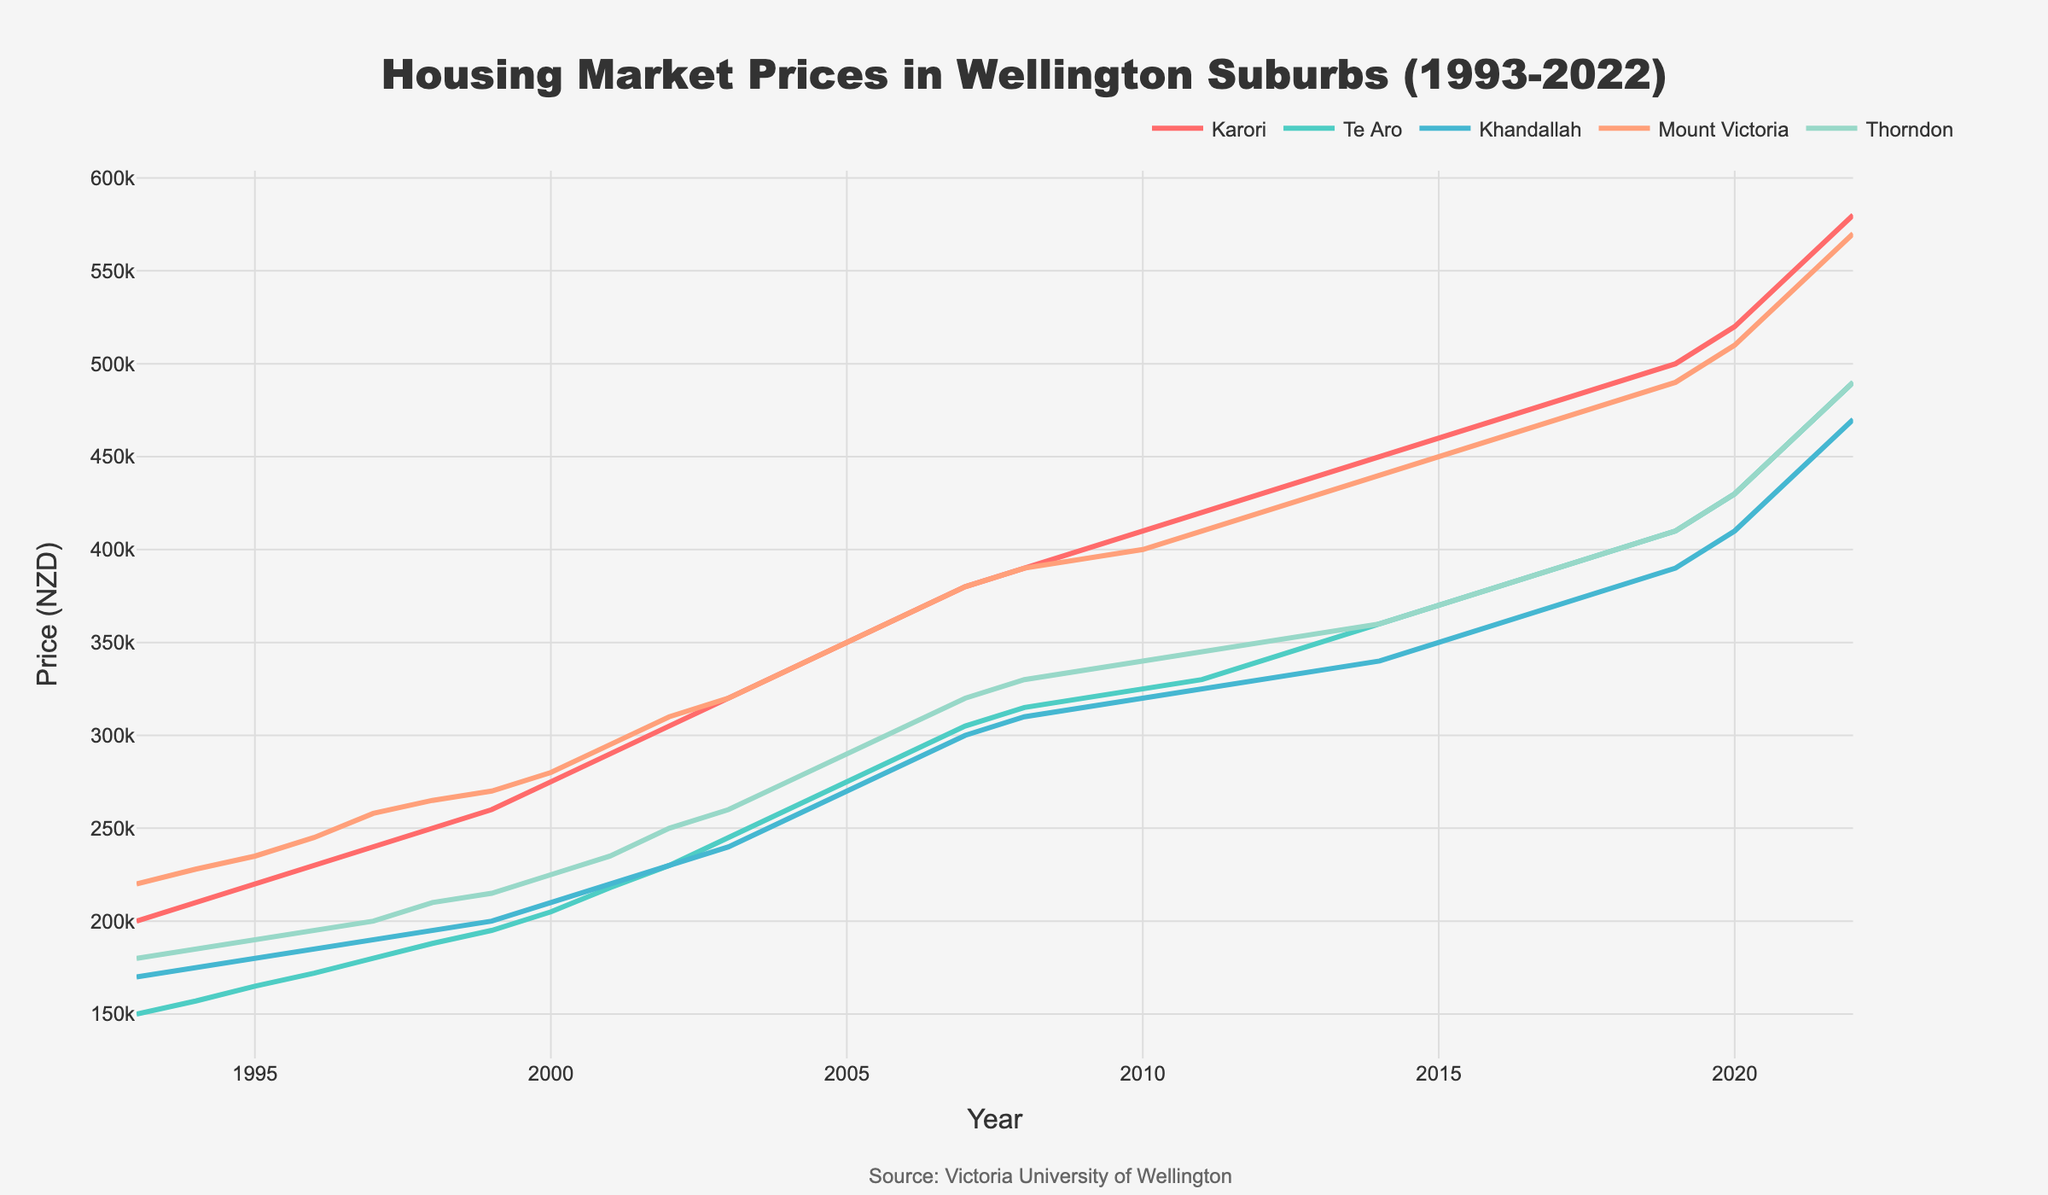What is the title of the time series plot? The title is usually found at the top of the figure and summarizes the main subject of the plot. Based on the provided data, the title should be addressing the housing market prices in Wellington suburbs over a certain period.
Answer: Housing Market Prices in Wellington Suburbs (1993-2022) Which suburb shows the highest housing market price in 2022? To determine this, look at the data points in 2022 for each suburb and identify the highest value. The highest housing market price can be found by examining the end points of each line on the plot.
Answer: Mount Victoria How did the housing market price in Karori change from 1993 to 2022? To answer this, observe the line representing Karori and see its starting (1993) and ending (2022) points. Calculate the difference between these two values to understand the price change.
Answer: Increased by 380,000 NZD By which year did Te Aro first reach a housing market price of at least 300,000 NZD? Identify the year when Te Aro's housing price data intersects the 300,000 NZD mark by tracing the Te Aro line to its first intersection with this value.
Answer: 2007 Which suburb had the most consistent increase in housing prices over the period? Consistent increase can be deduced by the smoothness and steadiness of the line representing each suburb. The suburb with the least fluctuations and a regular upward trend is deemed most consistent.
Answer: Karori Compare the housing market prices between Thorndon and Khandallah in 2010. Which is higher and by how much? Locate the data points for both Thorndon and Khandallah in 2010, then compare their values. Subtract the smaller value from the larger one to get the difference.
Answer: Thorndon is higher by 20,000 NZD What visual element is used to differentiate between the different suburbs in the plot? Observing the legend and the line styles, identify what feature (color, line type, etc.) is used to distinguish the suburbs on the plot. Each suburb is represented by a unique color.
Answer: Color What is the average housing market price for Mount Victoria over the three decades? Calculate the average by summing up the housing market prices of Mount Victoria from 1993 to 2022 and dividing by the number of data points (30 years).
Answer: 385,500 NZD In which year did Karori's housing market price surpass 400,000 NZD? Locate the year when the data line for Karori first crosses the 400,000 NZD mark by tracing Karori's trend line.
Answer: 2009 Which suburb experienced the greatest increase in housing market price between 2000 and 2022? Calculate the price change for each suburb from 2000 to 2022 by subtracting their values in 2000 from those in 2022, then compare the changes to find the largest increase.
Answer: Mount Victoria 